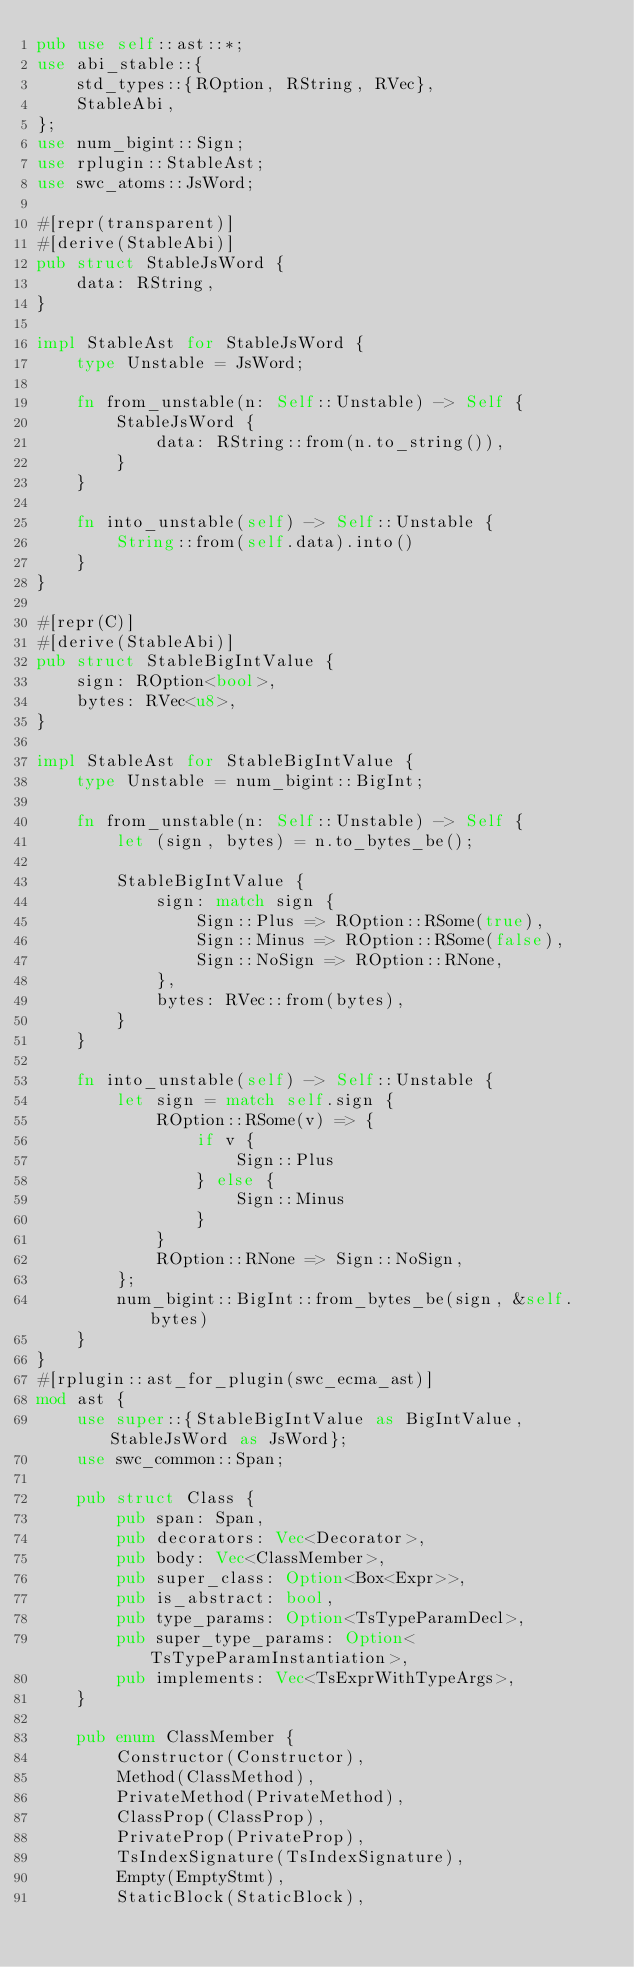Convert code to text. <code><loc_0><loc_0><loc_500><loc_500><_Rust_>pub use self::ast::*;
use abi_stable::{
    std_types::{ROption, RString, RVec},
    StableAbi,
};
use num_bigint::Sign;
use rplugin::StableAst;
use swc_atoms::JsWord;

#[repr(transparent)]
#[derive(StableAbi)]
pub struct StableJsWord {
    data: RString,
}

impl StableAst for StableJsWord {
    type Unstable = JsWord;

    fn from_unstable(n: Self::Unstable) -> Self {
        StableJsWord {
            data: RString::from(n.to_string()),
        }
    }

    fn into_unstable(self) -> Self::Unstable {
        String::from(self.data).into()
    }
}

#[repr(C)]
#[derive(StableAbi)]
pub struct StableBigIntValue {
    sign: ROption<bool>,
    bytes: RVec<u8>,
}

impl StableAst for StableBigIntValue {
    type Unstable = num_bigint::BigInt;

    fn from_unstable(n: Self::Unstable) -> Self {
        let (sign, bytes) = n.to_bytes_be();

        StableBigIntValue {
            sign: match sign {
                Sign::Plus => ROption::RSome(true),
                Sign::Minus => ROption::RSome(false),
                Sign::NoSign => ROption::RNone,
            },
            bytes: RVec::from(bytes),
        }
    }

    fn into_unstable(self) -> Self::Unstable {
        let sign = match self.sign {
            ROption::RSome(v) => {
                if v {
                    Sign::Plus
                } else {
                    Sign::Minus
                }
            }
            ROption::RNone => Sign::NoSign,
        };
        num_bigint::BigInt::from_bytes_be(sign, &self.bytes)
    }
}
#[rplugin::ast_for_plugin(swc_ecma_ast)]
mod ast {
    use super::{StableBigIntValue as BigIntValue, StableJsWord as JsWord};
    use swc_common::Span;

    pub struct Class {
        pub span: Span,
        pub decorators: Vec<Decorator>,
        pub body: Vec<ClassMember>,
        pub super_class: Option<Box<Expr>>,
        pub is_abstract: bool,
        pub type_params: Option<TsTypeParamDecl>,
        pub super_type_params: Option<TsTypeParamInstantiation>,
        pub implements: Vec<TsExprWithTypeArgs>,
    }

    pub enum ClassMember {
        Constructor(Constructor),
        Method(ClassMethod),
        PrivateMethod(PrivateMethod),
        ClassProp(ClassProp),
        PrivateProp(PrivateProp),
        TsIndexSignature(TsIndexSignature),
        Empty(EmptyStmt),
        StaticBlock(StaticBlock),</code> 